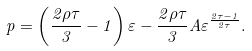<formula> <loc_0><loc_0><loc_500><loc_500>p = \left ( \frac { 2 \rho \tau } { 3 } - 1 \right ) \varepsilon - \frac { 2 \rho \tau } { 3 } A \varepsilon ^ { \frac { 2 \tau - 1 } { 2 \tau } } .</formula> 